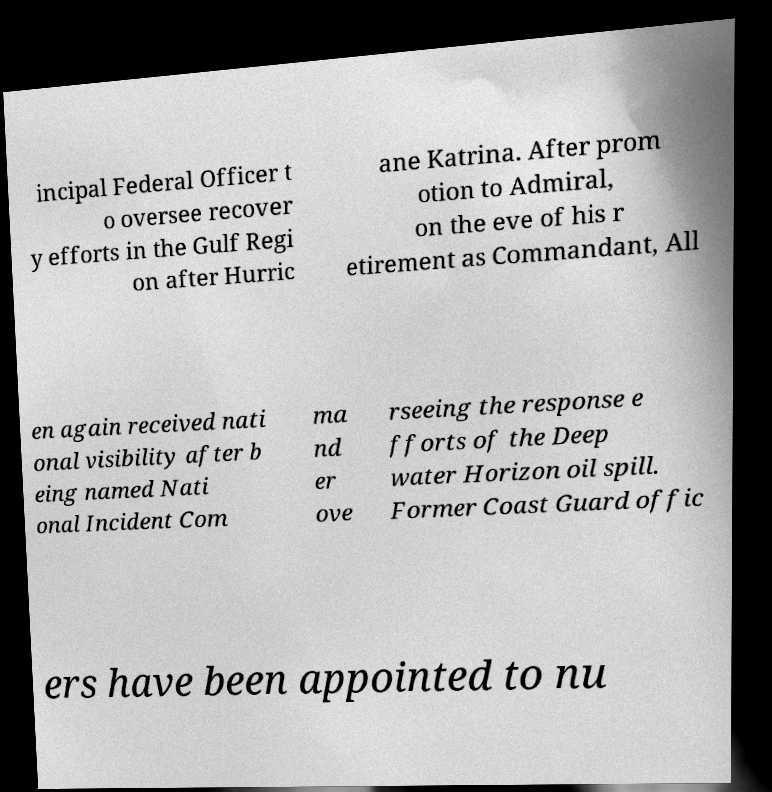Can you accurately transcribe the text from the provided image for me? incipal Federal Officer t o oversee recover y efforts in the Gulf Regi on after Hurric ane Katrina. After prom otion to Admiral, on the eve of his r etirement as Commandant, All en again received nati onal visibility after b eing named Nati onal Incident Com ma nd er ove rseeing the response e fforts of the Deep water Horizon oil spill. Former Coast Guard offic ers have been appointed to nu 